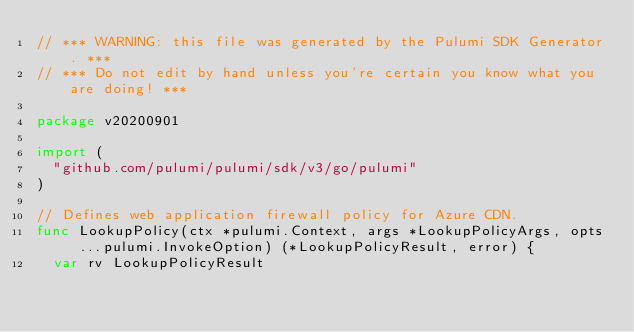Convert code to text. <code><loc_0><loc_0><loc_500><loc_500><_Go_>// *** WARNING: this file was generated by the Pulumi SDK Generator. ***
// *** Do not edit by hand unless you're certain you know what you are doing! ***

package v20200901

import (
	"github.com/pulumi/pulumi/sdk/v3/go/pulumi"
)

// Defines web application firewall policy for Azure CDN.
func LookupPolicy(ctx *pulumi.Context, args *LookupPolicyArgs, opts ...pulumi.InvokeOption) (*LookupPolicyResult, error) {
	var rv LookupPolicyResult</code> 